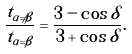<formula> <loc_0><loc_0><loc_500><loc_500>\frac { t _ { \alpha \neq \beta } } { t _ { \alpha = \beta } } = \frac { 3 - \cos \delta } { 3 + \cos \delta } .</formula> 